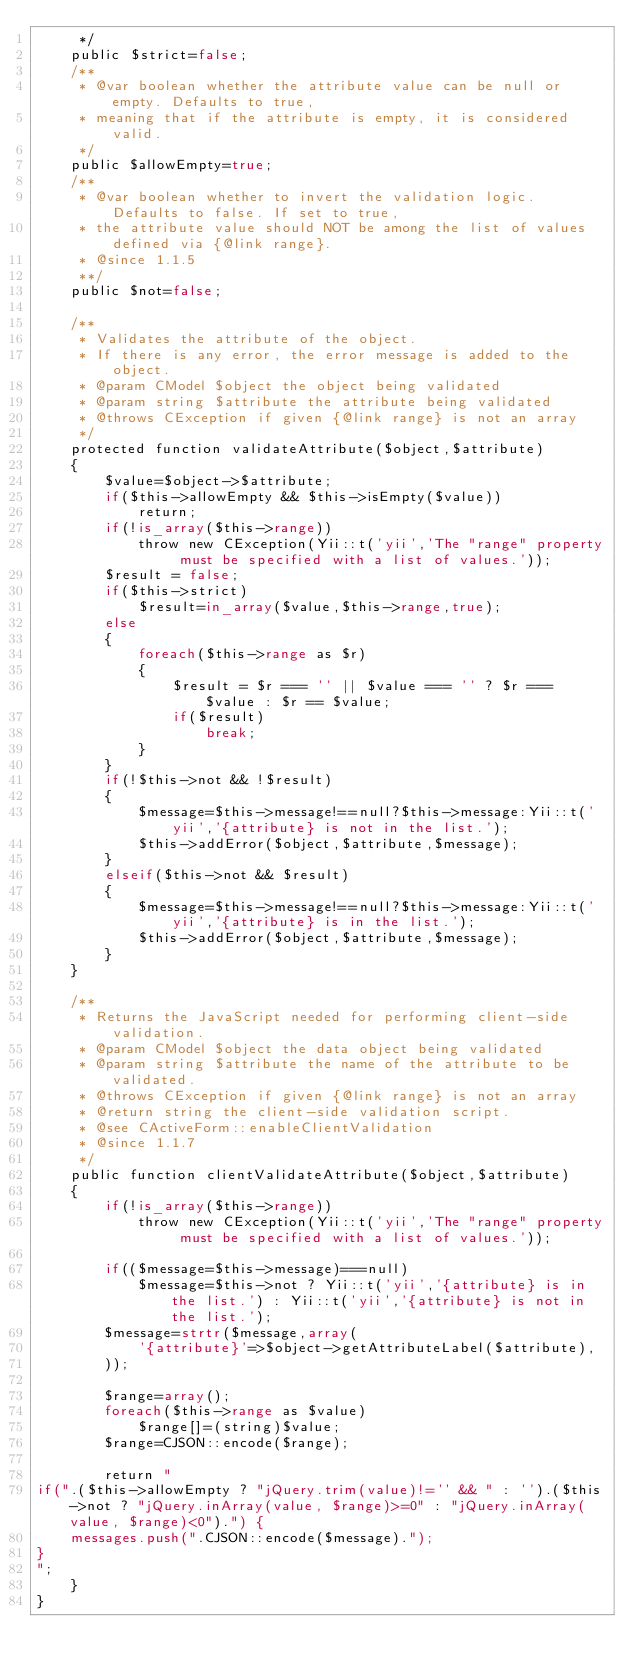<code> <loc_0><loc_0><loc_500><loc_500><_PHP_>	 */
	public $strict=false;
	/**
	 * @var boolean whether the attribute value can be null or empty. Defaults to true,
	 * meaning that if the attribute is empty, it is considered valid.
	 */
	public $allowEmpty=true;
	/**
	 * @var boolean whether to invert the validation logic. Defaults to false. If set to true,
	 * the attribute value should NOT be among the list of values defined via {@link range}.
	 * @since 1.1.5
	 **/
 	public $not=false;

	/**
	 * Validates the attribute of the object.
	 * If there is any error, the error message is added to the object.
	 * @param CModel $object the object being validated
	 * @param string $attribute the attribute being validated
	 * @throws CException if given {@link range} is not an array
	 */
	protected function validateAttribute($object,$attribute)
	{
		$value=$object->$attribute;
		if($this->allowEmpty && $this->isEmpty($value))
			return;
		if(!is_array($this->range))
			throw new CException(Yii::t('yii','The "range" property must be specified with a list of values.'));
		$result = false;
		if($this->strict)
			$result=in_array($value,$this->range,true);
		else
		{
			foreach($this->range as $r)
			{
				$result = $r === '' || $value === '' ? $r === $value : $r == $value;
				if($result)
					break;
			}
		}
		if(!$this->not && !$result)
		{
			$message=$this->message!==null?$this->message:Yii::t('yii','{attribute} is not in the list.');
			$this->addError($object,$attribute,$message);
		}
		elseif($this->not && $result)
		{
			$message=$this->message!==null?$this->message:Yii::t('yii','{attribute} is in the list.');
			$this->addError($object,$attribute,$message);
		}
	}

	/**
	 * Returns the JavaScript needed for performing client-side validation.
	 * @param CModel $object the data object being validated
	 * @param string $attribute the name of the attribute to be validated.
	 * @throws CException if given {@link range} is not an array
	 * @return string the client-side validation script.
	 * @see CActiveForm::enableClientValidation
	 * @since 1.1.7
	 */
	public function clientValidateAttribute($object,$attribute)
	{
		if(!is_array($this->range))
			throw new CException(Yii::t('yii','The "range" property must be specified with a list of values.'));

		if(($message=$this->message)===null)
			$message=$this->not ? Yii::t('yii','{attribute} is in the list.') : Yii::t('yii','{attribute} is not in the list.');
		$message=strtr($message,array(
			'{attribute}'=>$object->getAttributeLabel($attribute),
		));

		$range=array();
		foreach($this->range as $value)
			$range[]=(string)$value;
		$range=CJSON::encode($range);

		return "
if(".($this->allowEmpty ? "jQuery.trim(value)!='' && " : '').($this->not ? "jQuery.inArray(value, $range)>=0" : "jQuery.inArray(value, $range)<0").") {
	messages.push(".CJSON::encode($message).");
}
";
	}
}</code> 